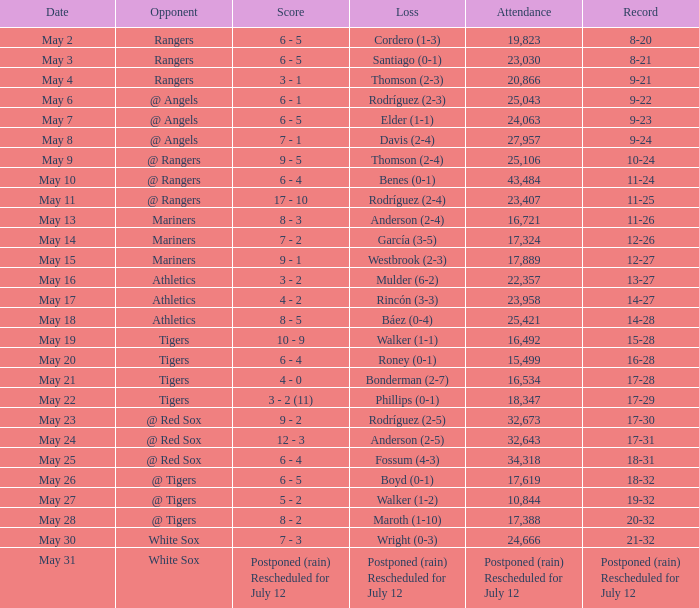What was the Indians record during the game that had 19,823 fans attending? 8-20. 